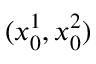Convert formula to latex. <formula><loc_0><loc_0><loc_500><loc_500>( x _ { 0 } ^ { 1 } , x _ { 0 } ^ { 2 } )</formula> 